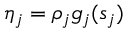<formula> <loc_0><loc_0><loc_500><loc_500>\eta _ { j } = \rho _ { j } g _ { j } ( s _ { j } )</formula> 